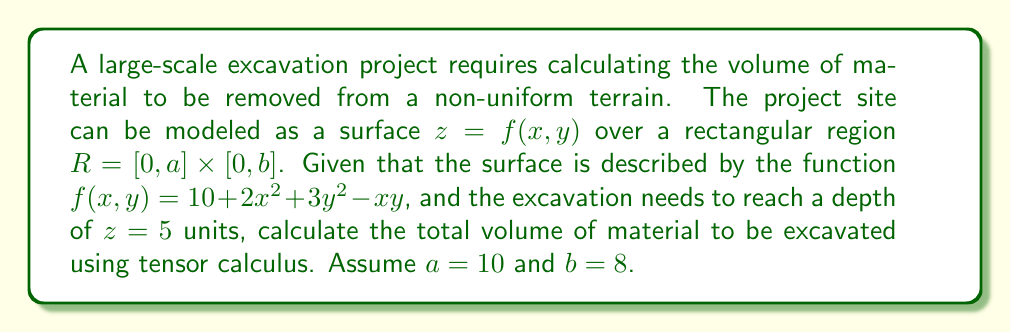Help me with this question. To solve this problem using tensor calculus, we'll follow these steps:

1) The volume to be excavated is the difference between the surface $z = f(x,y)$ and the plane $z = 5$, integrated over the region $R$.

2) We can express this as a triple integral:

   $$V = \int\int\int_V dV = \int_0^a \int_0^b \int_5^{f(x,y)} dz dy dx$$

3) Substituting the given function:

   $$V = \int_0^{10} \int_0^8 \int_5^{10 + 2x^2 + 3y^2 - xy} dz dy dx$$

4) Evaluating the innermost integral:

   $$V = \int_0^{10} \int_0^8 [10 + 2x^2 + 3y^2 - xy - 5] dy dx$$

   $$V = \int_0^{10} \int_0^8 [5 + 2x^2 + 3y^2 - xy] dy dx$$

5) This is now a double integral. Let's evaluate the inner integral with respect to y:

   $$V = \int_0^{10} [5y + 2x^2y + y^3 - \frac{1}{2}xy^2]_0^8 dx$$

   $$V = \int_0^{10} [40 + 16x^2 + 512 - 32xy]_0^8 dx$$

   $$V = \int_0^{10} [552 + 16x^2 - 256x] dx$$

6) Now we evaluate the outer integral:

   $$V = [552x + \frac{16}{3}x^3 - 128x^2]_0^{10}$$

   $$V = (5520 + \frac{16000}{3} - 12800) - (0 + 0 - 0)$$

   $$V = 5520 + 5333.33 - 12800$$

7) Simplifying:

   $$V = -1946.67$$

The negative sign indicates that we're excavating below the reference plane.
Answer: $1946.67$ cubic units 